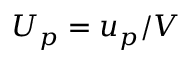Convert formula to latex. <formula><loc_0><loc_0><loc_500><loc_500>U _ { p } = u _ { p } / V</formula> 